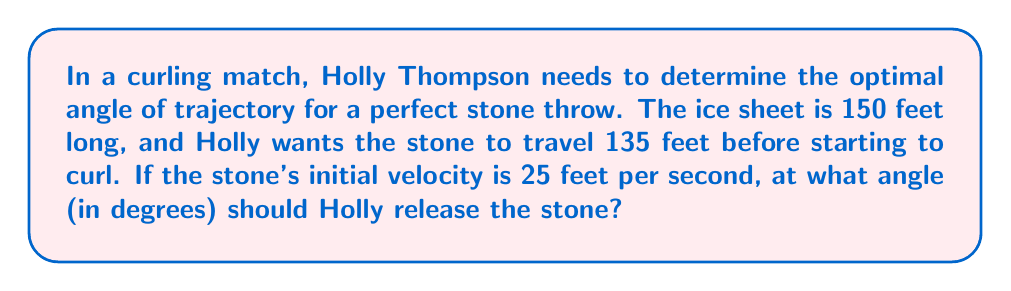Can you solve this math problem? Let's approach this step-by-step using the principles of projectile motion:

1) In curling, we can consider the stone's motion as a projectile until it starts to curl. We'll use the range equation for a projectile:

   $$R = \frac{v^2 \sin(2\theta)}{g}$$

   Where:
   $R$ is the range (135 feet)
   $v$ is the initial velocity (25 feet/second)
   $\theta$ is the angle of release (what we're solving for)
   $g$ is the acceleration due to gravity (32 feet/second²)

2) Substitute the known values into the equation:

   $$135 = \frac{25^2 \sin(2\theta)}{32}$$

3) Simplify:

   $$135 = \frac{625 \sin(2\theta)}{32}$$

4) Multiply both sides by 32:

   $$4320 = 625 \sin(2\theta)$$

5) Divide both sides by 625:

   $$6.912 = \sin(2\theta)$$

6) Take the inverse sine (arcsin) of both sides:

   $$\theta = \frac{1}{2} \arcsin(6.912)$$

7) Calculate:

   $$\theta \approx 43.97°$$

[asy]
import geometry;

size(200);
draw((0,0)--(150,0), arrow=Arrow(TeXHead));
draw((0,0)--(0,50), arrow=Arrow(TeXHead));
draw((0,0)--(135,50), arrow=Arrow(TeXHead));

label("150 ft", (75,-5));
label("135 ft", (67.5,30));
label("$\theta$", (10,5));

dot((0,0));
dot((135,50));
[/asy]
Answer: $43.97°$ 